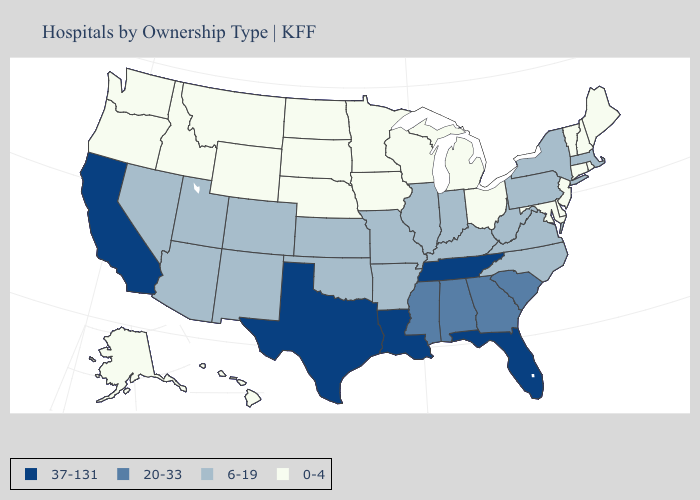Does Maryland have the lowest value in the South?
Short answer required. Yes. Name the states that have a value in the range 37-131?
Short answer required. California, Florida, Louisiana, Tennessee, Texas. Which states have the lowest value in the USA?
Concise answer only. Alaska, Connecticut, Delaware, Hawaii, Idaho, Iowa, Maine, Maryland, Michigan, Minnesota, Montana, Nebraska, New Hampshire, New Jersey, North Dakota, Ohio, Oregon, Rhode Island, South Dakota, Vermont, Washington, Wisconsin, Wyoming. Name the states that have a value in the range 37-131?
Answer briefly. California, Florida, Louisiana, Tennessee, Texas. What is the highest value in states that border Texas?
Write a very short answer. 37-131. Name the states that have a value in the range 37-131?
Keep it brief. California, Florida, Louisiana, Tennessee, Texas. Does North Dakota have the same value as Delaware?
Give a very brief answer. Yes. Name the states that have a value in the range 6-19?
Answer briefly. Arizona, Arkansas, Colorado, Illinois, Indiana, Kansas, Kentucky, Massachusetts, Missouri, Nevada, New Mexico, New York, North Carolina, Oklahoma, Pennsylvania, Utah, Virginia, West Virginia. Does the first symbol in the legend represent the smallest category?
Answer briefly. No. What is the lowest value in the West?
Be succinct. 0-4. Does Hawaii have the lowest value in the USA?
Short answer required. Yes. What is the value of Wyoming?
Short answer required. 0-4. What is the value of Alabama?
Quick response, please. 20-33. Among the states that border Vermont , does New York have the lowest value?
Give a very brief answer. No. Name the states that have a value in the range 37-131?
Give a very brief answer. California, Florida, Louisiana, Tennessee, Texas. 